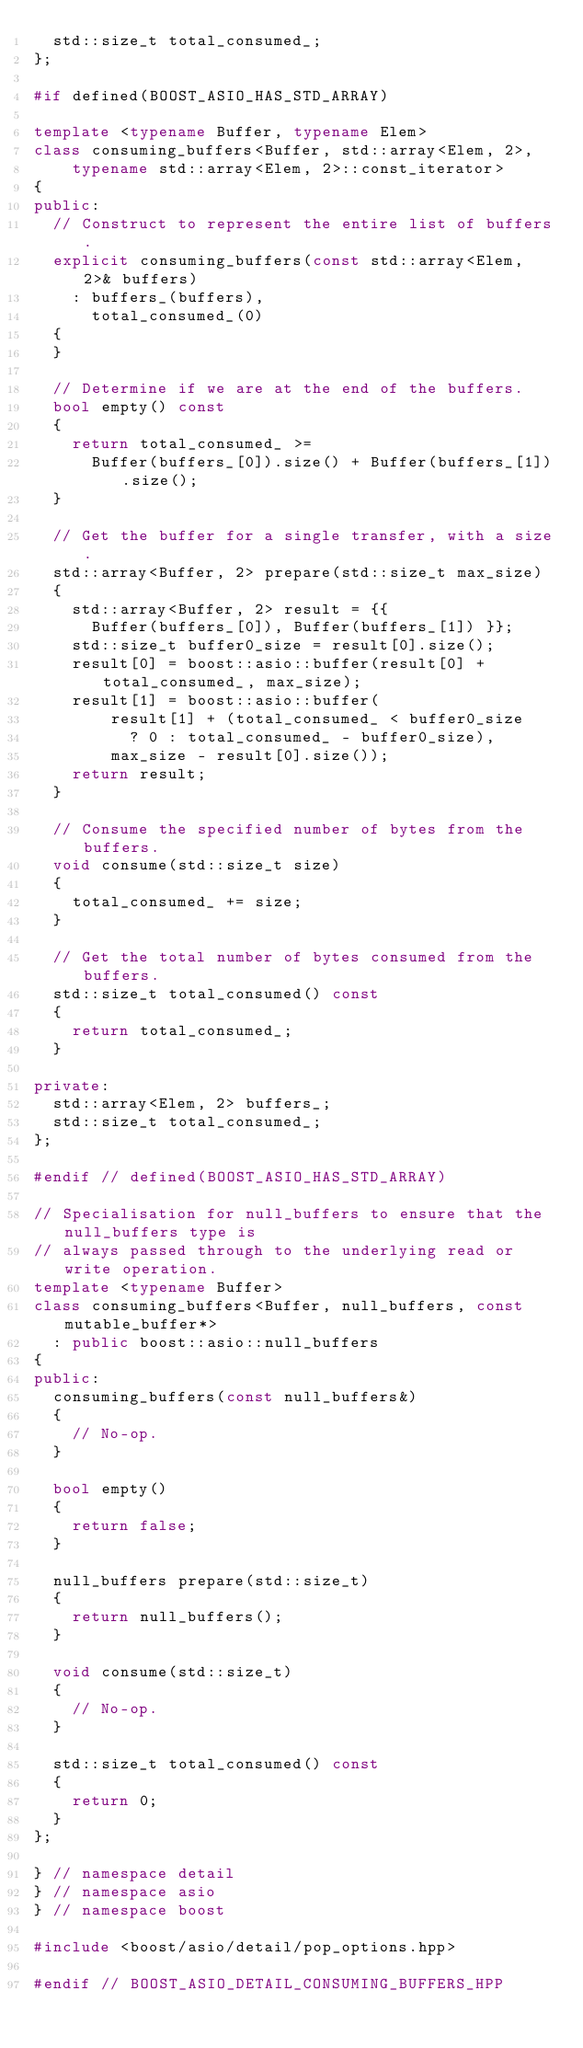Convert code to text. <code><loc_0><loc_0><loc_500><loc_500><_C++_>  std::size_t total_consumed_;
};

#if defined(BOOST_ASIO_HAS_STD_ARRAY)

template <typename Buffer, typename Elem>
class consuming_buffers<Buffer, std::array<Elem, 2>,
    typename std::array<Elem, 2>::const_iterator>
{
public:
  // Construct to represent the entire list of buffers.
  explicit consuming_buffers(const std::array<Elem, 2>& buffers)
    : buffers_(buffers),
      total_consumed_(0)
  {
  }

  // Determine if we are at the end of the buffers.
  bool empty() const
  {
    return total_consumed_ >=
      Buffer(buffers_[0]).size() + Buffer(buffers_[1]).size();
  }

  // Get the buffer for a single transfer, with a size.
  std::array<Buffer, 2> prepare(std::size_t max_size)
  {
    std::array<Buffer, 2> result = {{
      Buffer(buffers_[0]), Buffer(buffers_[1]) }};
    std::size_t buffer0_size = result[0].size();
    result[0] = boost::asio::buffer(result[0] + total_consumed_, max_size);
    result[1] = boost::asio::buffer(
        result[1] + (total_consumed_ < buffer0_size
          ? 0 : total_consumed_ - buffer0_size),
        max_size - result[0].size());
    return result;
  }

  // Consume the specified number of bytes from the buffers.
  void consume(std::size_t size)
  {
    total_consumed_ += size;
  }

  // Get the total number of bytes consumed from the buffers.
  std::size_t total_consumed() const
  {
    return total_consumed_;
  }

private:
  std::array<Elem, 2> buffers_;
  std::size_t total_consumed_;
};

#endif // defined(BOOST_ASIO_HAS_STD_ARRAY)

// Specialisation for null_buffers to ensure that the null_buffers type is
// always passed through to the underlying read or write operation.
template <typename Buffer>
class consuming_buffers<Buffer, null_buffers, const mutable_buffer*>
  : public boost::asio::null_buffers
{
public:
  consuming_buffers(const null_buffers&)
  {
    // No-op.
  }

  bool empty()
  {
    return false;
  }

  null_buffers prepare(std::size_t)
  {
    return null_buffers();
  }

  void consume(std::size_t)
  {
    // No-op.
  }

  std::size_t total_consumed() const
  {
    return 0;
  }
};

} // namespace detail
} // namespace asio
} // namespace boost

#include <boost/asio/detail/pop_options.hpp>

#endif // BOOST_ASIO_DETAIL_CONSUMING_BUFFERS_HPP
</code> 